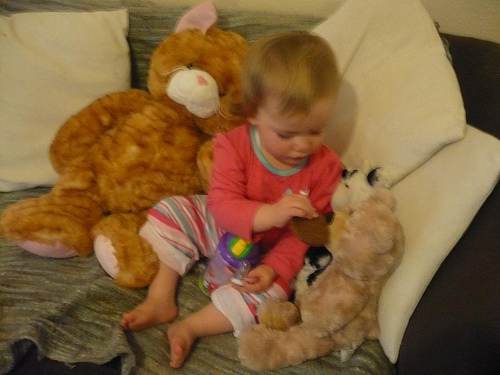<image>What is the person wearing on their feet? The person is not wearing anything on their feet. What car is the baby's shirt? The color of the baby's shirt is ambiguous. It can be seen as pink, pink and blue, or black. What is the person wearing on their feet? The person is not wearing anything on their feet. What car is the baby's shirt? The baby's shirt is pink. 